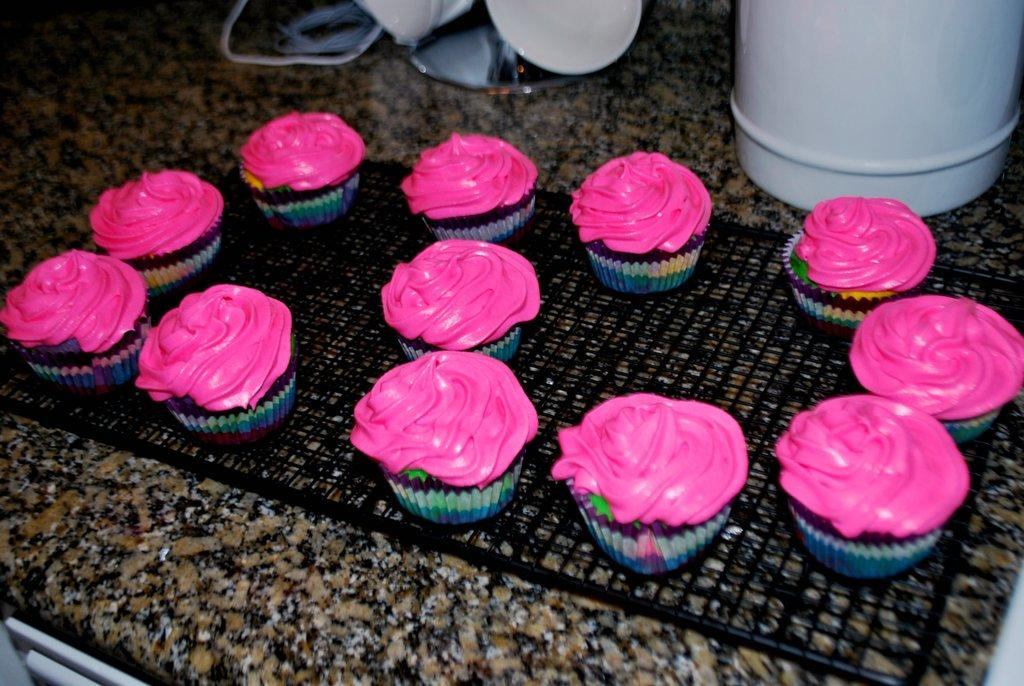What type of food can be seen on the object in the image? There are cupcakes on an object in the image. What other items can be found on the kitchen slab in the image? There are other objects on a kitchen slab in the image, but their specific nature is not mentioned in the provided facts. Can you describe the surface where the cupcakes and other objects are placed? The cupcakes and other objects are placed on a kitchen slab in the image. What type of window can be seen in the image? There is no window present in the image; it only features cupcakes on an object and other objects on a kitchen slab. What type of stew is being prepared on the kitchen slab in the image? There is no stew present in the image; it only features cupcakes on an object and other objects on a kitchen slab. 